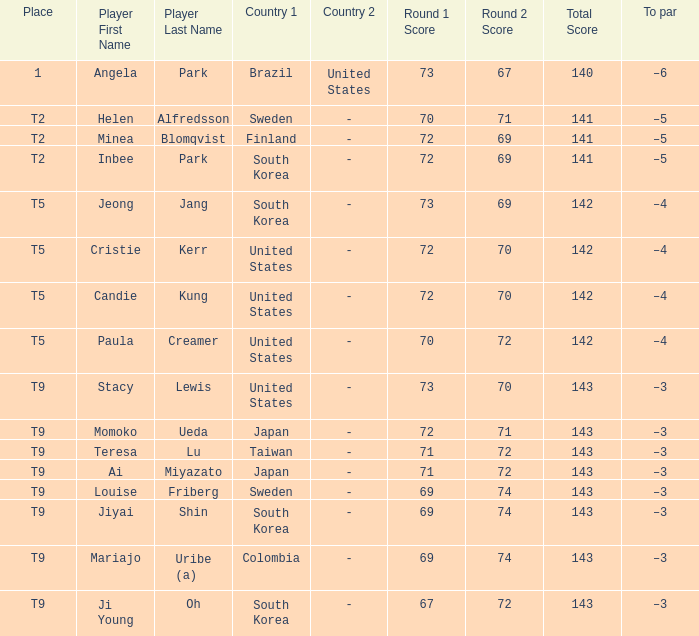What was Momoko Ueda's place? T9. 